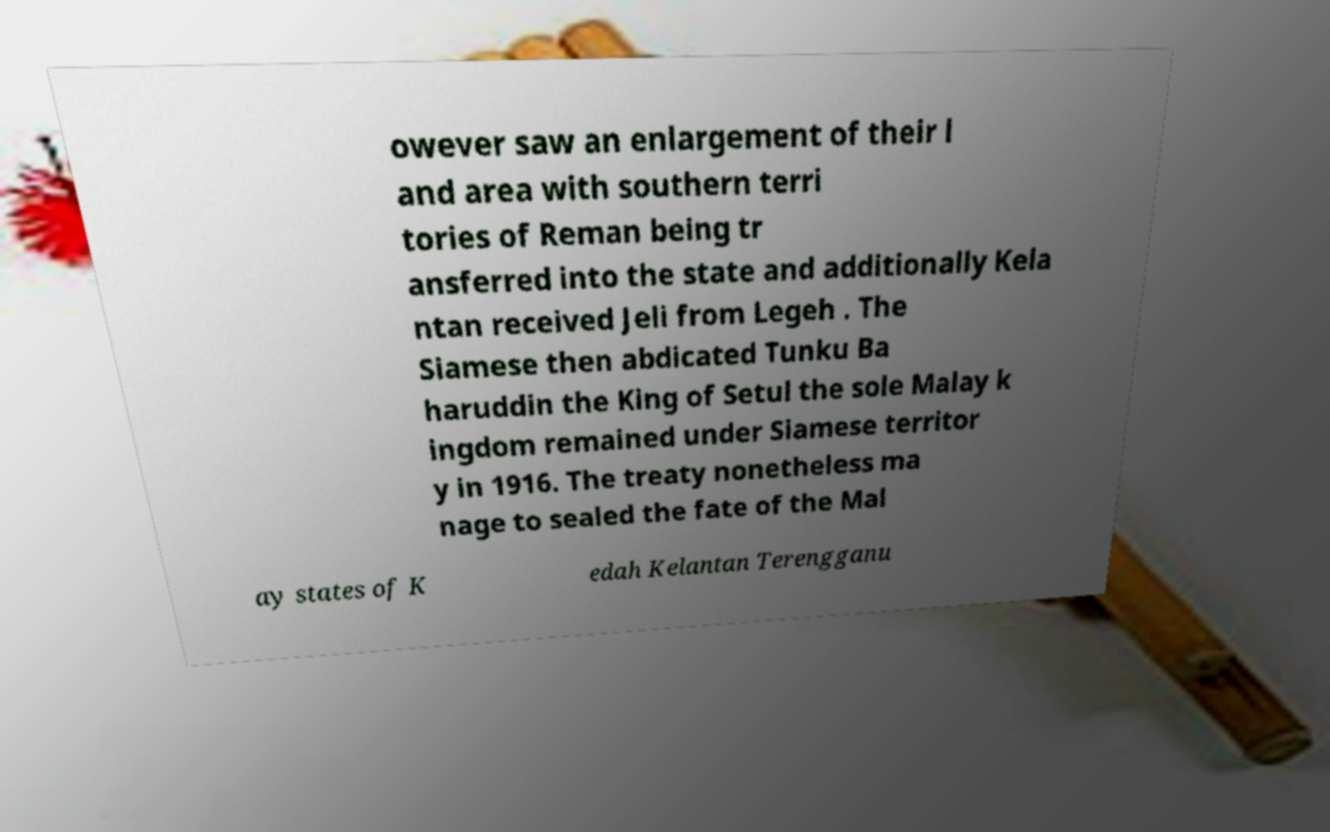I need the written content from this picture converted into text. Can you do that? owever saw an enlargement of their l and area with southern terri tories of Reman being tr ansferred into the state and additionally Kela ntan received Jeli from Legeh . The Siamese then abdicated Tunku Ba haruddin the King of Setul the sole Malay k ingdom remained under Siamese territor y in 1916. The treaty nonetheless ma nage to sealed the fate of the Mal ay states of K edah Kelantan Terengganu 